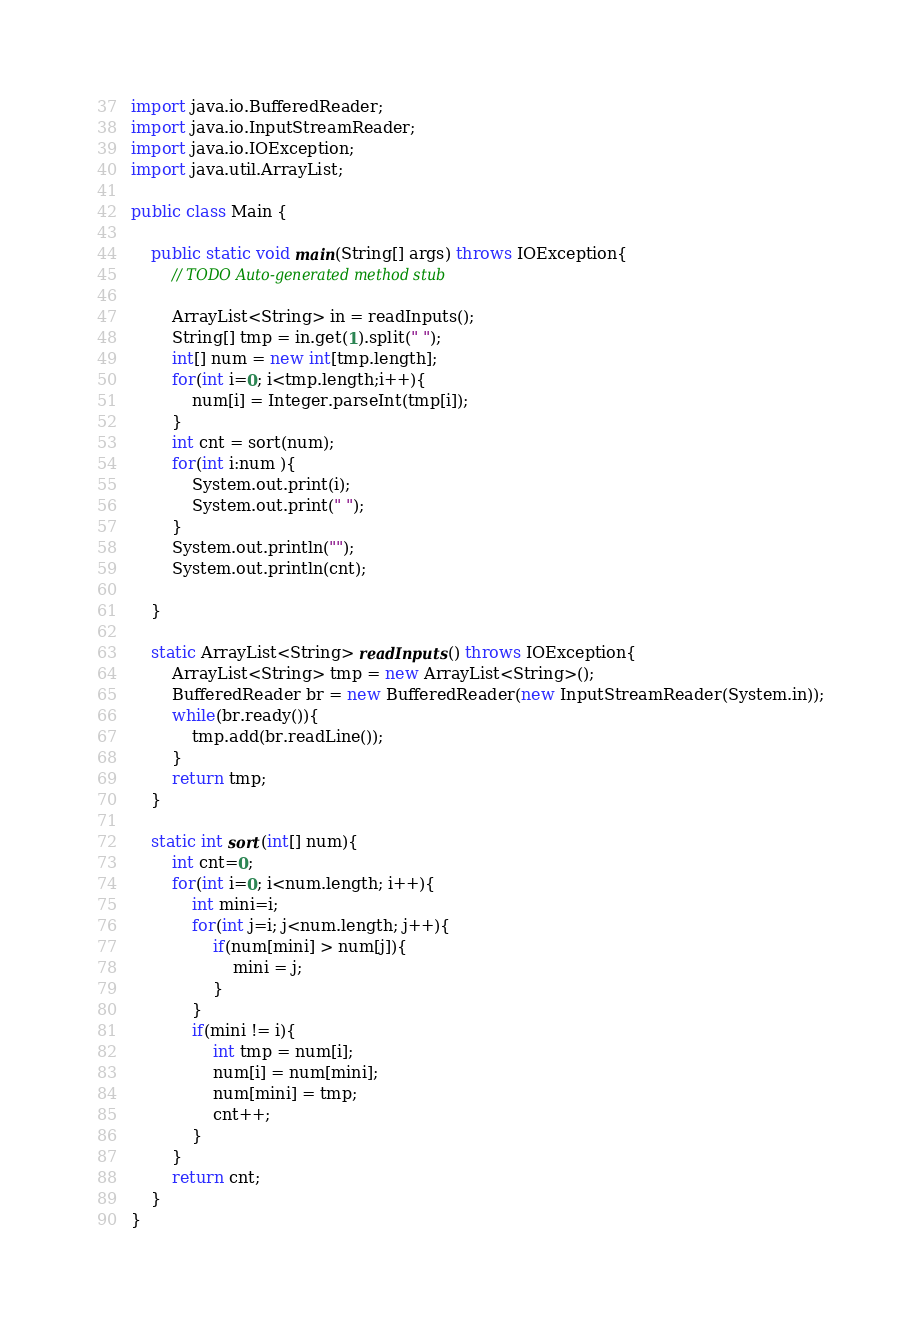<code> <loc_0><loc_0><loc_500><loc_500><_Java_>import java.io.BufferedReader;
import java.io.InputStreamReader;
import java.io.IOException;
import java.util.ArrayList;

public class Main {

	public static void main(String[] args) throws IOException{
		// TODO Auto-generated method stub

		ArrayList<String> in = readInputs();
		String[] tmp = in.get(1).split(" ");
		int[] num = new int[tmp.length];
		for(int i=0; i<tmp.length;i++){
			num[i] = Integer.parseInt(tmp[i]);
		}
		int cnt = sort(num);
		for(int i:num ){
			System.out.print(i);
			System.out.print(" ");
		}
		System.out.println("");
		System.out.println(cnt);

	}
	
	static ArrayList<String> readInputs() throws IOException{
		ArrayList<String> tmp = new ArrayList<String>();
		BufferedReader br = new BufferedReader(new InputStreamReader(System.in));
		while(br.ready()){
			tmp.add(br.readLine());
		}
		return tmp;
	}

	static int sort(int[] num){
		int cnt=0;
		for(int i=0; i<num.length; i++){
			int mini=i;
			for(int j=i; j<num.length; j++){
				if(num[mini] > num[j]){
					mini = j;
				}
			}
			if(mini != i){
				int tmp = num[i];
				num[i] = num[mini];
				num[mini] = tmp;
				cnt++;
			}
		}
		return cnt;
	}
}</code> 